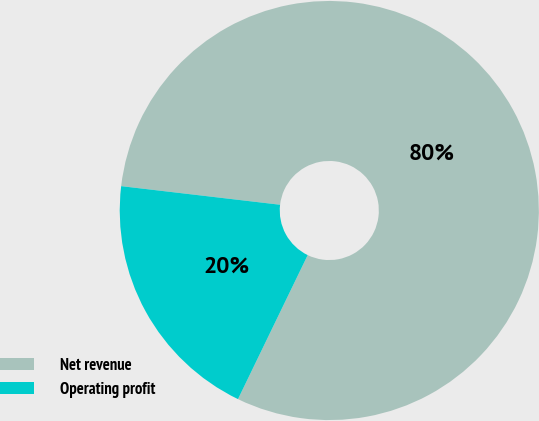Convert chart to OTSL. <chart><loc_0><loc_0><loc_500><loc_500><pie_chart><fcel>Net revenue<fcel>Operating profit<nl><fcel>80.32%<fcel>19.68%<nl></chart> 